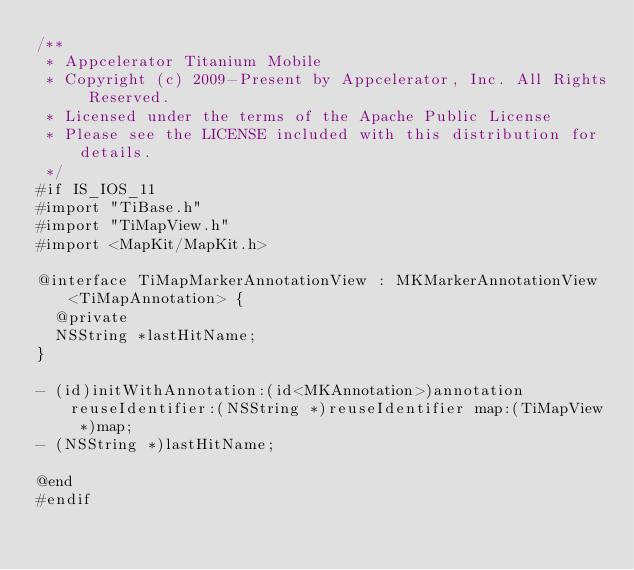<code> <loc_0><loc_0><loc_500><loc_500><_C_>/**
 * Appcelerator Titanium Mobile
 * Copyright (c) 2009-Present by Appcelerator, Inc. All Rights Reserved.
 * Licensed under the terms of the Apache Public License
 * Please see the LICENSE included with this distribution for details.
 */
#if IS_IOS_11
#import "TiBase.h"
#import "TiMapView.h"
#import <MapKit/MapKit.h>

@interface TiMapMarkerAnnotationView : MKMarkerAnnotationView <TiMapAnnotation> {
  @private
  NSString *lastHitName;
}

- (id)initWithAnnotation:(id<MKAnnotation>)annotation reuseIdentifier:(NSString *)reuseIdentifier map:(TiMapView *)map;
- (NSString *)lastHitName;

@end
#endif
</code> 